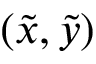Convert formula to latex. <formula><loc_0><loc_0><loc_500><loc_500>( \tilde { x } , \tilde { y } )</formula> 